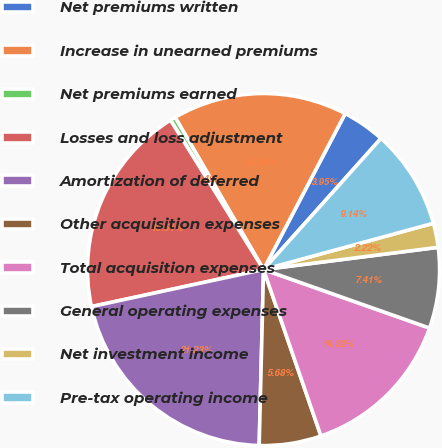Convert chart. <chart><loc_0><loc_0><loc_500><loc_500><pie_chart><fcel>Net premiums written<fcel>Increase in unearned premiums<fcel>Net premiums earned<fcel>Losses and loss adjustment<fcel>Amortization of deferred<fcel>Other acquisition expenses<fcel>Total acquisition expenses<fcel>General operating expenses<fcel>Net investment income<fcel>Pre-tax operating income<nl><fcel>3.95%<fcel>16.05%<fcel>0.49%<fcel>19.51%<fcel>21.23%<fcel>5.68%<fcel>14.32%<fcel>7.41%<fcel>2.22%<fcel>9.14%<nl></chart> 